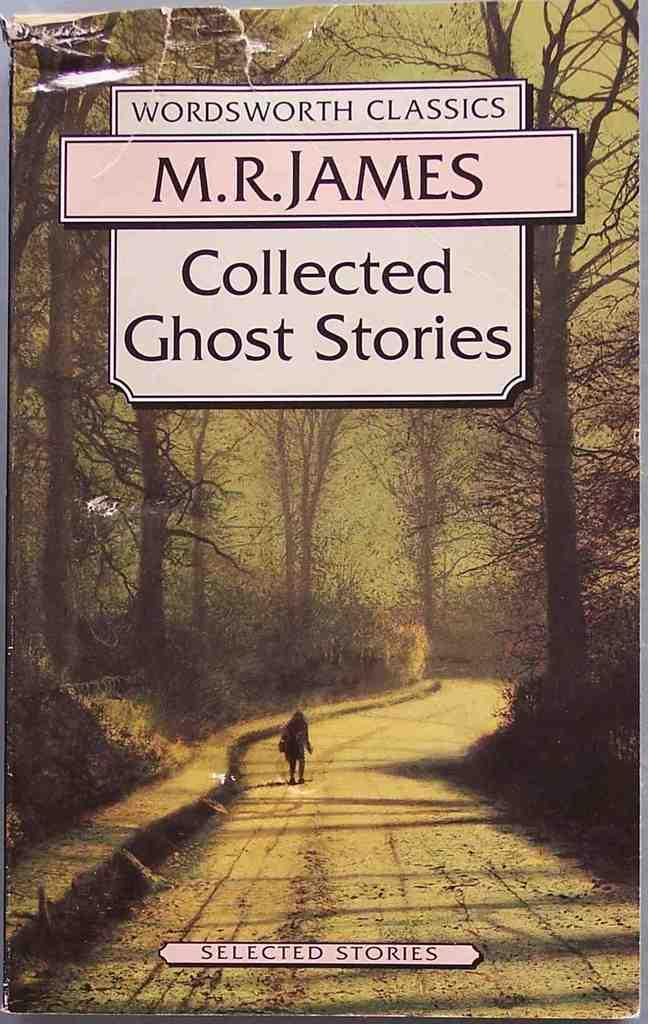<image>
Relay a brief, clear account of the picture shown. some collected ghost stories with an illustration on it 